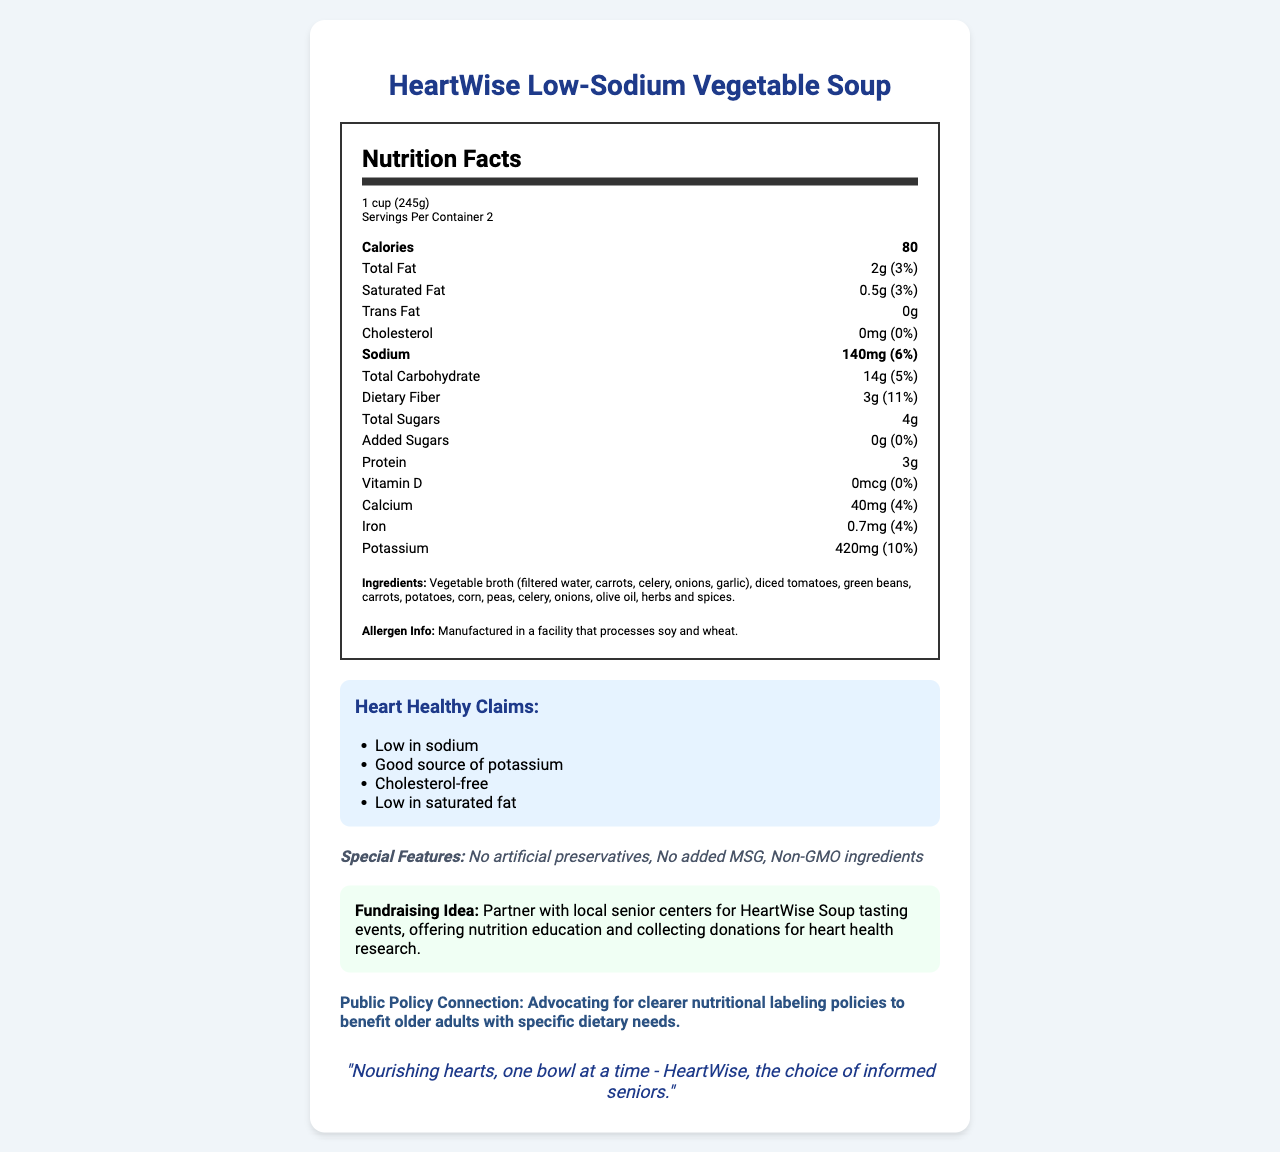what is the product name? The product name is stated at the beginning of the document, "HeartWise Low-Sodium Vegetable Soup."
Answer: HeartWise Low-Sodium Vegetable Soup what is the serving size and servings per container? The serving size is listed as "1 cup (245g)" and servings per container as "2."
Answer: 1 cup (245g), 2 servings per container how many calories are in one serving? The document states 80 calories per serving in the nutrition facts.
Answer: 80 calories what is the total fat content per serving? The total fat content per serving is listed as 2g.
Answer: 2g what percentage of the daily value for dietary fiber does one serving provide? The document indicates that one serving contains 11% of the daily value for dietary fiber.
Answer: 11% what are the heart-healthy claims of this product? The heart-healthy claims are explicitly listed in the document under "Heart Healthy Claims."
Answer: Low in sodium, Good source of potassium, Cholesterol-free, Low in saturated fat what is the main ingredient in the soup? The main ingredient is "Vegetable broth (filtered water, carrots, celery, onions, garlic)" as listed first in the ingredient section.
Answer: Vegetable broth (filtered water, carrots, celery, onions, garlic) which of the following is NOT a special feature of the product? A. Non-GMO ingredients B. Contains artificial preservatives C. No added MSG The special features listed include "No artificial preservatives," "No added MSG," and "Non-GMO ingredients."
Answer: B. Contains artificial preservatives what is the amount of sodium per serving and its daily value percentage? The sodium content per serving is 140mg, which is 6% of the daily value.
Answer: 140mg, 6% based on the document, should this soup be considered heart-healthy? The soup is considered heart-healthy because it is low in sodium, low in saturated fat, cholesterol-free, and a good source of potassium, as emphasized in the document under "Heart Healthy Claims."
Answer: Yes what is the amount of potassium per serving? The document lists the potassium content as 420mg per serving.
Answer: 420mg what are the fundraising ideas mentioned in the document? The fundraising idea is clearly described in the document under "Fundraising Idea."
Answer: Partner with local senior centers for HeartWise Soup tasting events, offering nutrition education and collecting donations for heart health research. which nutrients have a daily value percentage of 4% per serving? A. Calcium and Iron B. Vitamin D and Protein C. Calcium and Potassium The document states that calcium and iron both have a daily value percentage of 4% per serving.
Answer: A. Calcium and Iron does this product contain trans fat? The document specifies that the trans fat content is 0g, indicating no trans fat in this product.
Answer: No what does the document suggest about public policy? The document mentions a public policy connection, advocating for clearer nutritional labeling policies.
Answer: Advocating for clearer nutritional labeling policies to benefit older adults with specific dietary needs. summarize the document The summary collects the key points about the product's nutritional information, heart-healthy claims, special features, fundraising ideas, public policy connection, and marketing slogan.
Answer: The document provides the nutrition facts for HeartWise Low-Sodium Vegetable Soup, emphasizing its heart-healthy attributes with low sodium, low saturated fat, cholesterol-free, and good potassium source. It includes special features like no artificial preservatives and non-GMO ingredients. Fundraising ideas such as partnering with local senior centers are mentioned, along with a public policy connection for better nutritional labeling. The marketing slogan is also noted. what is the mission of the company based on the fundraising idea? The document discusses fundraising ideas but does not provide explicit information about the company's mission.
Answer: Not enough information 